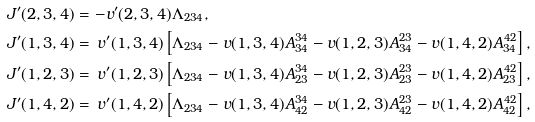Convert formula to latex. <formula><loc_0><loc_0><loc_500><loc_500>J ^ { \prime } ( 2 , 3 , 4 ) & = - v ^ { \prime } ( 2 , 3 , 4 ) \Lambda _ { 2 3 4 } , \\ J ^ { \prime } ( 1 , 3 , 4 ) & = \, v ^ { \prime } ( 1 , 3 , 4 ) \left [ \Lambda _ { 2 3 4 } - v ( 1 , 3 , 4 ) A ^ { 3 4 } _ { 3 4 } - v ( 1 , 2 , 3 ) A ^ { 2 3 } _ { 3 4 } - v ( 1 , 4 , 2 ) A ^ { 4 2 } _ { 3 4 } \right ] , \\ J ^ { \prime } ( 1 , 2 , 3 ) & = \, v ^ { \prime } ( 1 , 2 , 3 ) \left [ \Lambda _ { 2 3 4 } - v ( 1 , 3 , 4 ) A ^ { 3 4 } _ { 2 3 } - v ( 1 , 2 , 3 ) A ^ { 2 3 } _ { 2 3 } - v ( 1 , 4 , 2 ) A ^ { 4 2 } _ { 2 3 } \right ] , \\ J ^ { \prime } ( 1 , 4 , 2 ) & = \, v ^ { \prime } ( 1 , 4 , 2 ) \left [ \Lambda _ { 2 3 4 } - v ( 1 , 3 , 4 ) A ^ { 3 4 } _ { 4 2 } - v ( 1 , 2 , 3 ) A ^ { 2 3 } _ { 4 2 } - v ( 1 , 4 , 2 ) A ^ { 4 2 } _ { 4 2 } \right ] ,</formula> 